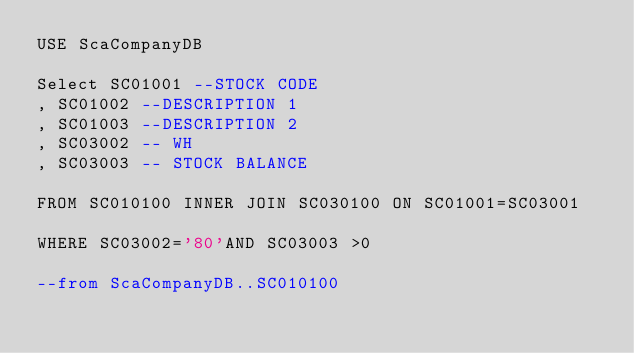<code> <loc_0><loc_0><loc_500><loc_500><_SQL_>USE ScaCompanyDB

Select SC01001 --STOCK CODE
, SC01002 --DESCRIPTION 1
, SC01003 --DESCRIPTION 2
, SC03002 -- WH
, SC03003 -- STOCK BALANCE

FROM SC010100 INNER JOIN SC030100 ON SC01001=SC03001 

WHERE SC03002='80'AND SC03003 >0

--from ScaCompanyDB..SC010100</code> 